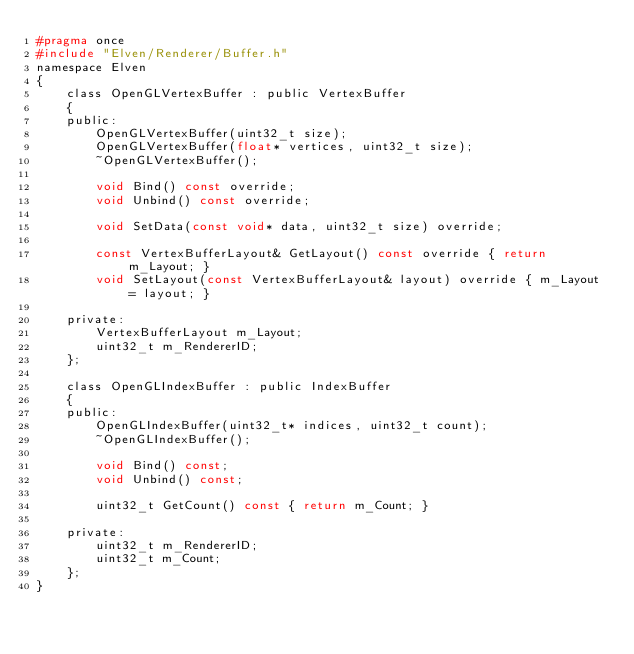Convert code to text. <code><loc_0><loc_0><loc_500><loc_500><_C_>#pragma once
#include "Elven/Renderer/Buffer.h"
namespace Elven
{
    class OpenGLVertexBuffer : public VertexBuffer
    {
    public:
        OpenGLVertexBuffer(uint32_t size);
        OpenGLVertexBuffer(float* vertices, uint32_t size);
        ~OpenGLVertexBuffer();

        void Bind() const override;
        void Unbind() const override;

        void SetData(const void* data, uint32_t size) override;

        const VertexBufferLayout& GetLayout() const override { return m_Layout; }
        void SetLayout(const VertexBufferLayout& layout) override { m_Layout = layout; }

    private:
        VertexBufferLayout m_Layout;
        uint32_t m_RendererID;
    };

    class OpenGLIndexBuffer : public IndexBuffer
    {
    public:
        OpenGLIndexBuffer(uint32_t* indices, uint32_t count);
        ~OpenGLIndexBuffer();

        void Bind() const;
        void Unbind() const;

        uint32_t GetCount() const { return m_Count; }

    private:
        uint32_t m_RendererID;
        uint32_t m_Count;
    };
}

</code> 